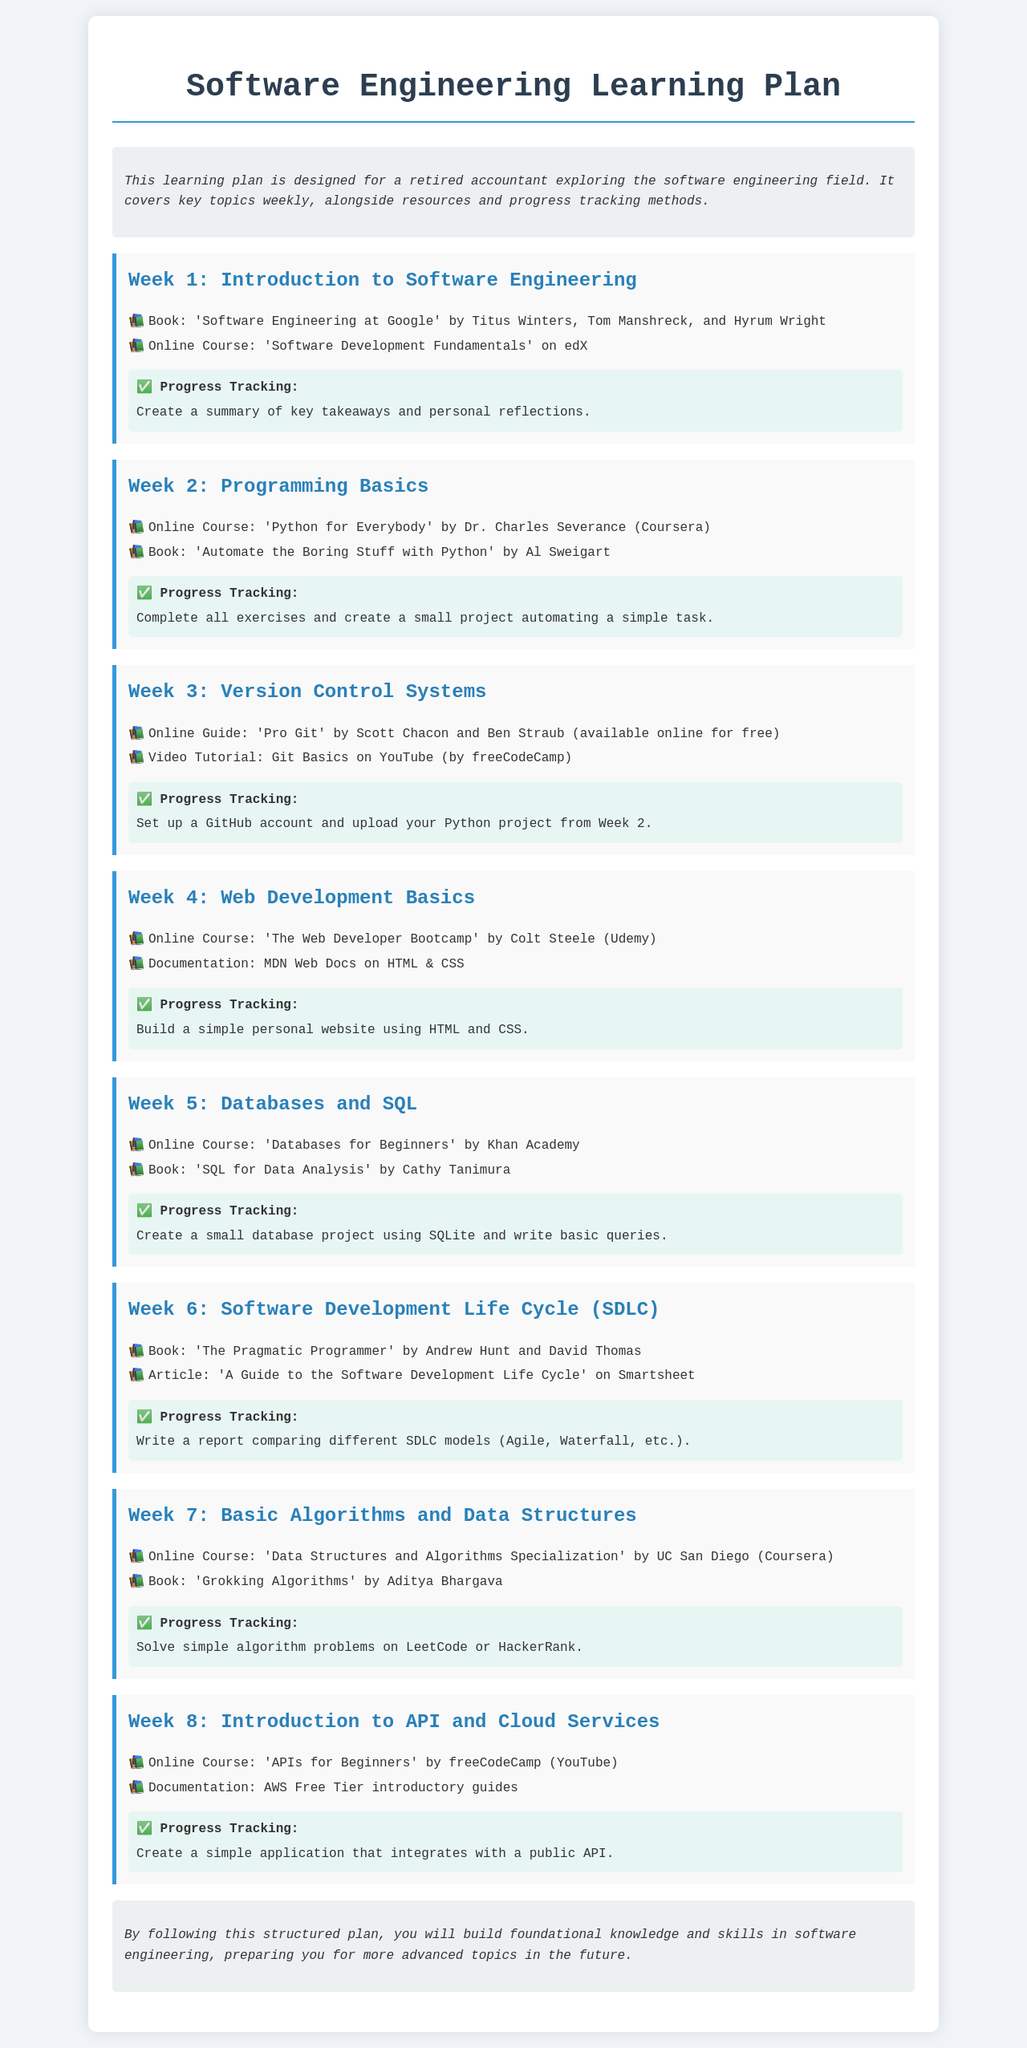What is the title of the learning plan? The title is stated at the top of the document and summarizes the content clearly.
Answer: Software Engineering Learning Plan How many weeks are outlined in the learning plan? The number of weeks is indicated by the number of sections that begin with "Week".
Answer: 8 What book is recommended for Week 5? The document lists specific books for each week, including this one in Week 5.
Answer: SQL for Data Analysis What is the primary resource for learning Version Control Systems? The document specifies a primary resource for this topic under Week 3.
Answer: Pro Git What project is suggested at the end of Week 4? The learning plan includes a specific project to complete by the end of Week 4.
Answer: Build a simple personal website using HTML and CSS Which programming language is focused on in Week 2? The document specifically mentions a programming language as part of the curriculum in Week 2.
Answer: Python What is the primary focus of Week 6? The key topic of focus is highlighted in the title and associated resources for this week.
Answer: Software Development Life Cycle What type of application should be created in Week 8? The document describes a specific type of application to be created during this week.
Answer: A simple application that integrates with a public API 